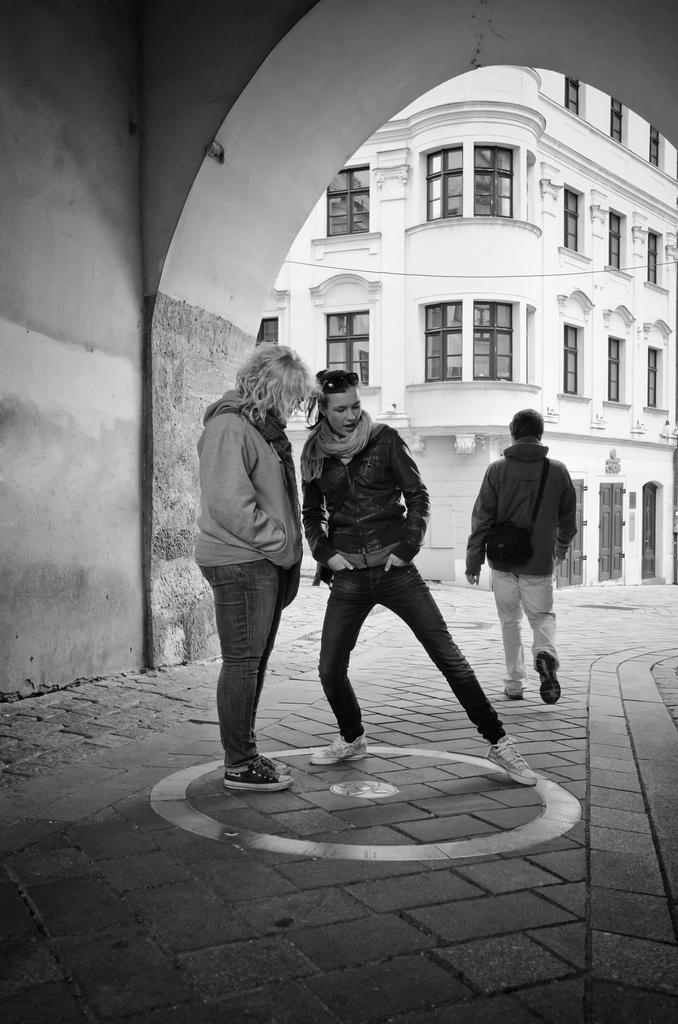How many people are in the image? There are three persons in the image. What are the positions of two of the persons? Two of the persons are standing. What is the third person doing in the image? One person is walking on the road. What can be seen in the background of the image? There is a building in the background of the image. What feature of the building is mentioned? The building has windows. What type of pig can be seen playing with a beam in the image? There is no pig or beam present in the image. What effect does the pig have on the building in the image? There is no pig in the image, so it cannot have any effect on the building. 